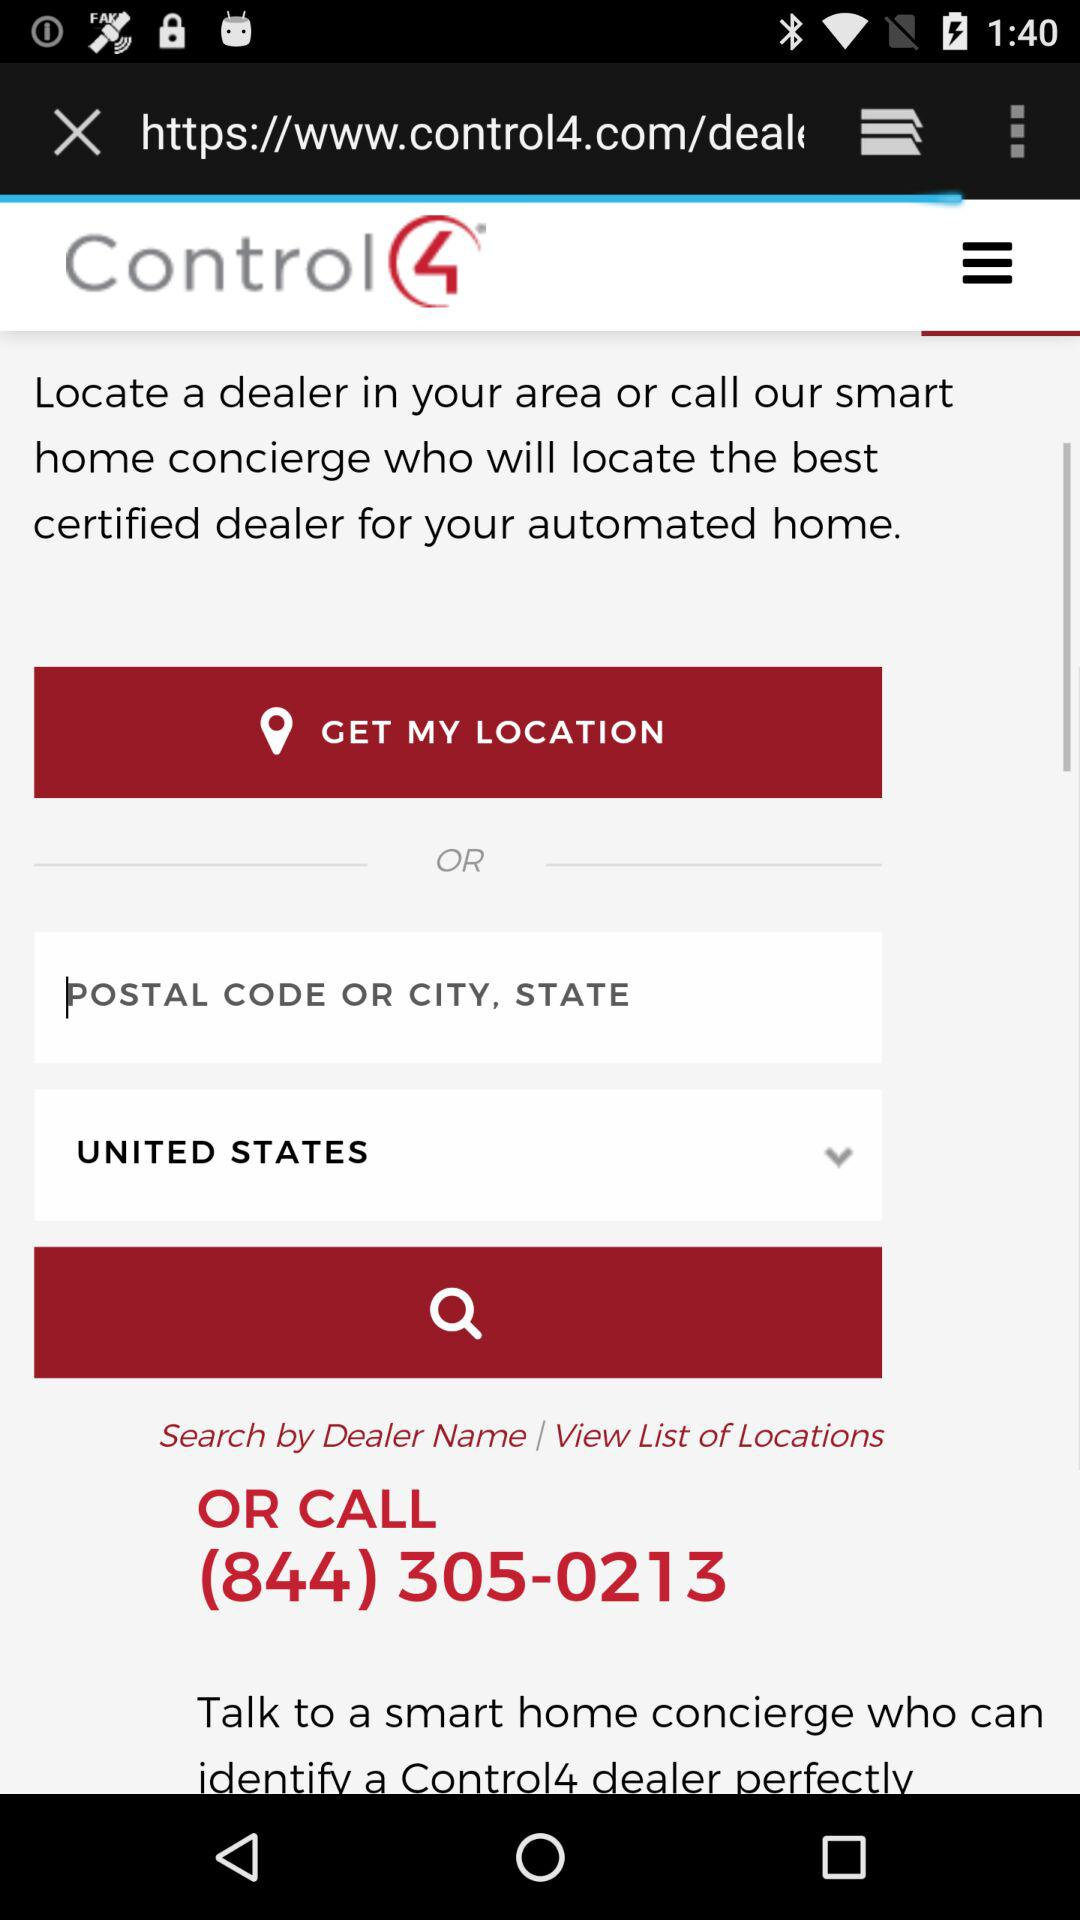What is the entered location?
When the provided information is insufficient, respond with <no answer>. <no answer> 